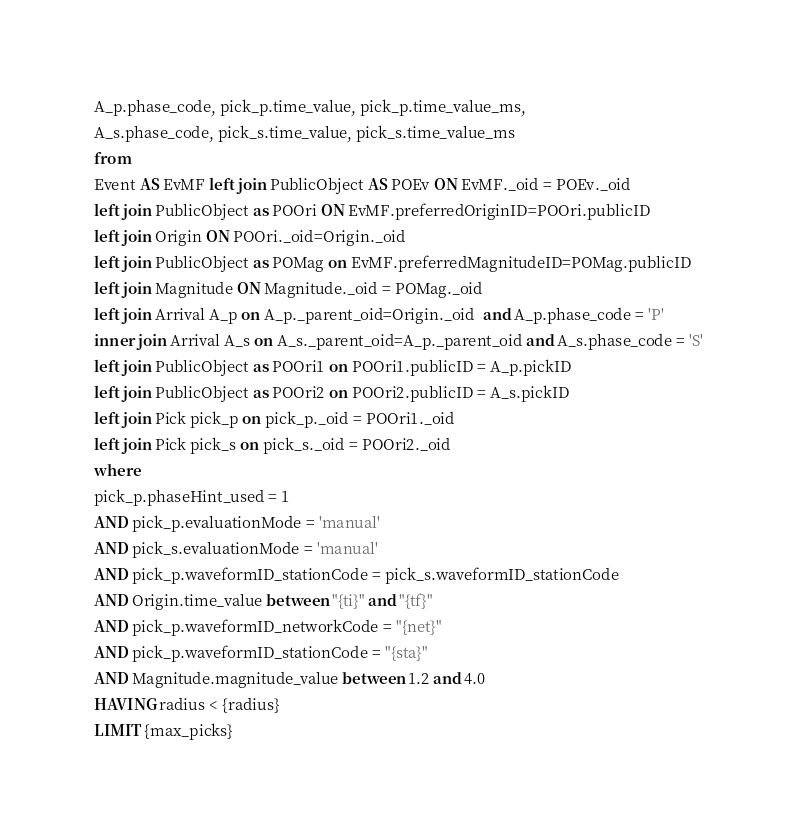Convert code to text. <code><loc_0><loc_0><loc_500><loc_500><_SQL_>A_p.phase_code, pick_p.time_value, pick_p.time_value_ms,
A_s.phase_code, pick_s.time_value, pick_s.time_value_ms
from
Event AS EvMF left join PublicObject AS POEv ON EvMF._oid = POEv._oid
left join PublicObject as POOri ON EvMF.preferredOriginID=POOri.publicID
left join Origin ON POOri._oid=Origin._oid
left join PublicObject as POMag on EvMF.preferredMagnitudeID=POMag.publicID
left join Magnitude ON Magnitude._oid = POMag._oid
left join Arrival A_p on A_p._parent_oid=Origin._oid  and A_p.phase_code = 'P'
inner join Arrival A_s on A_s._parent_oid=A_p._parent_oid and A_s.phase_code = 'S'
left join PublicObject as POOri1 on POOri1.publicID = A_p.pickID
left join PublicObject as POOri2 on POOri2.publicID = A_s.pickID
left join Pick pick_p on pick_p._oid = POOri1._oid
left join Pick pick_s on pick_s._oid = POOri2._oid
where
pick_p.phaseHint_used = 1
AND pick_p.evaluationMode = 'manual'
AND pick_s.evaluationMode = 'manual'
AND pick_p.waveformID_stationCode = pick_s.waveformID_stationCode
AND Origin.time_value between "{ti}" and "{tf}"
AND pick_p.waveformID_networkCode = "{net}" 
AND pick_p.waveformID_stationCode = "{sta}" 
AND Magnitude.magnitude_value between 1.2 and 4.0
HAVING radius < {radius}
LIMIT {max_picks}</code> 